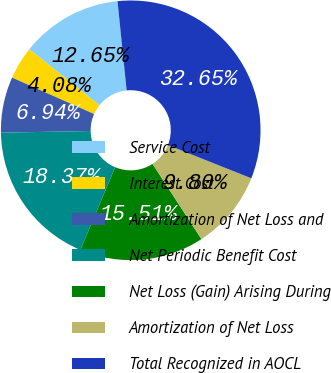Convert chart. <chart><loc_0><loc_0><loc_500><loc_500><pie_chart><fcel>Service Cost<fcel>Interest Cost<fcel>Amortization of Net Loss and<fcel>Net Periodic Benefit Cost<fcel>Net Loss (Gain) Arising During<fcel>Amortization of Net Loss<fcel>Total Recognized in AOCL<nl><fcel>12.65%<fcel>4.08%<fcel>6.94%<fcel>18.37%<fcel>15.51%<fcel>9.8%<fcel>32.65%<nl></chart> 